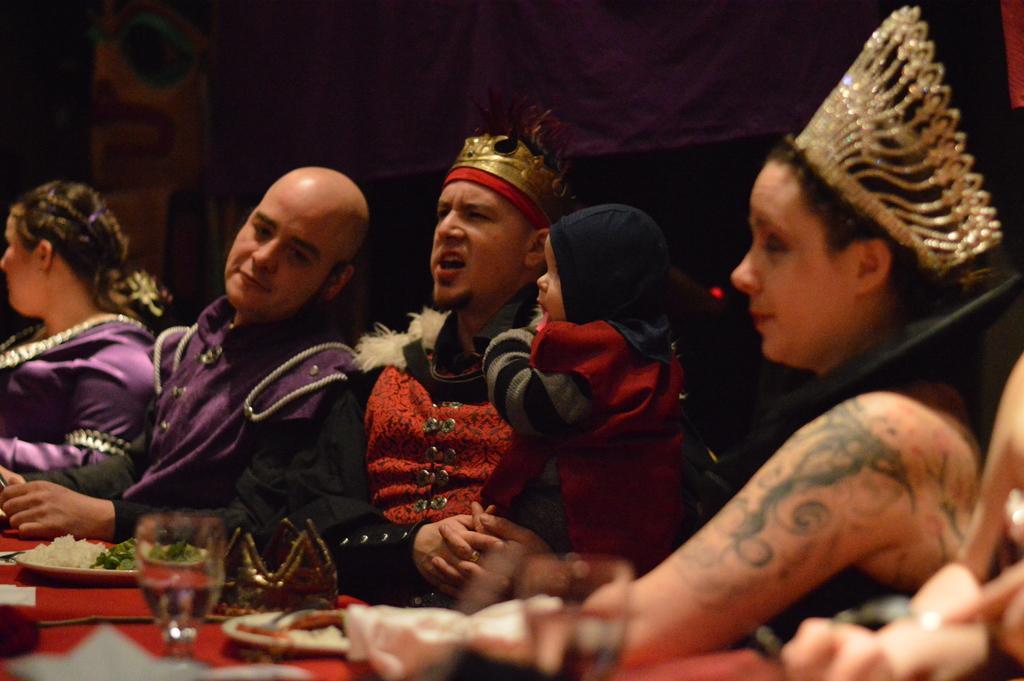Can you describe this image briefly? In the picture I can see four persons. I can see a man in the middle of the image and he is carrying a baby. I can see the red color cloth on the table. I can see the plates and a glass on the table. I can see a woman on the left side and the right side as well. 